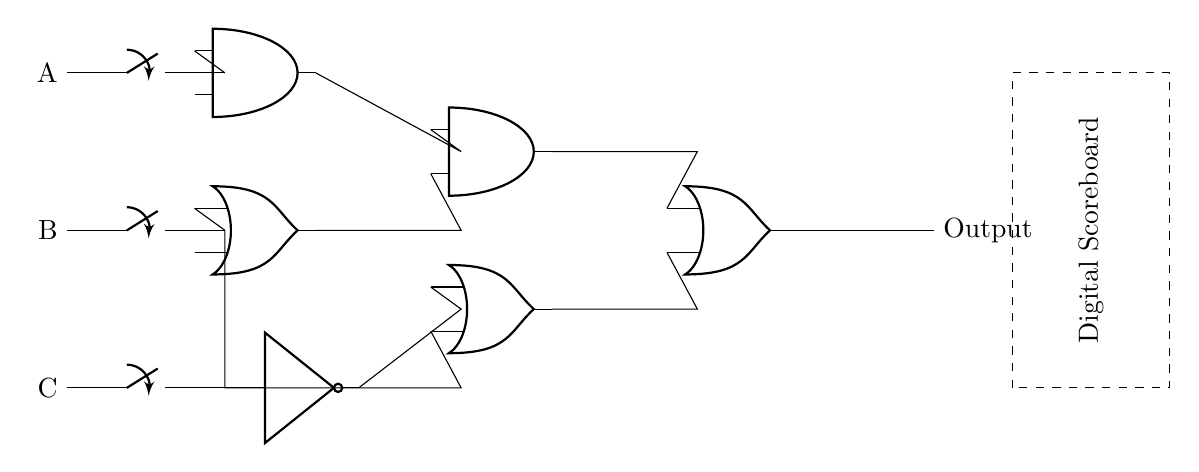What type of logic gate is used at the top? The top gate in the diagram is an AND gate, which outputs true only if all inputs are true.
Answer: AND What are the total number of input switches in this circuit? The circuit has three input switches labeled A, B, and C, which are used to provide the inputs for the logic gates.
Answer: 3 What is the function of the NOT gate in this circuit? The NOT gate inverts the input signal from switch C, meaning it outputs the opposite value of whatever C is.
Answer: Inversion What is the output of the AND gate based on the inputs? The output of the AND gate depends on the simultaneous states of its inputs. It will only output high if both inputs are high.
Answer: Conditional How does the OR gate function in this circuit? The OR gate takes two inputs and outputs high if at least one of the inputs is high, providing a way to combine signals from the AND gate and the NOT gate.
Answer: Combination What signifies the digital scoreboard in the circuit? The dashed rectangle labeled ‘Digital Scoreboard’ indicates where the final output is displayed, showing the result of the logic operations performed.
Answer: Display What type of gate is placed at the bottom of the circuit? The bottom gate in the diagram is an OR gate, which outputs true if at least one of its inputs is true.
Answer: OR 